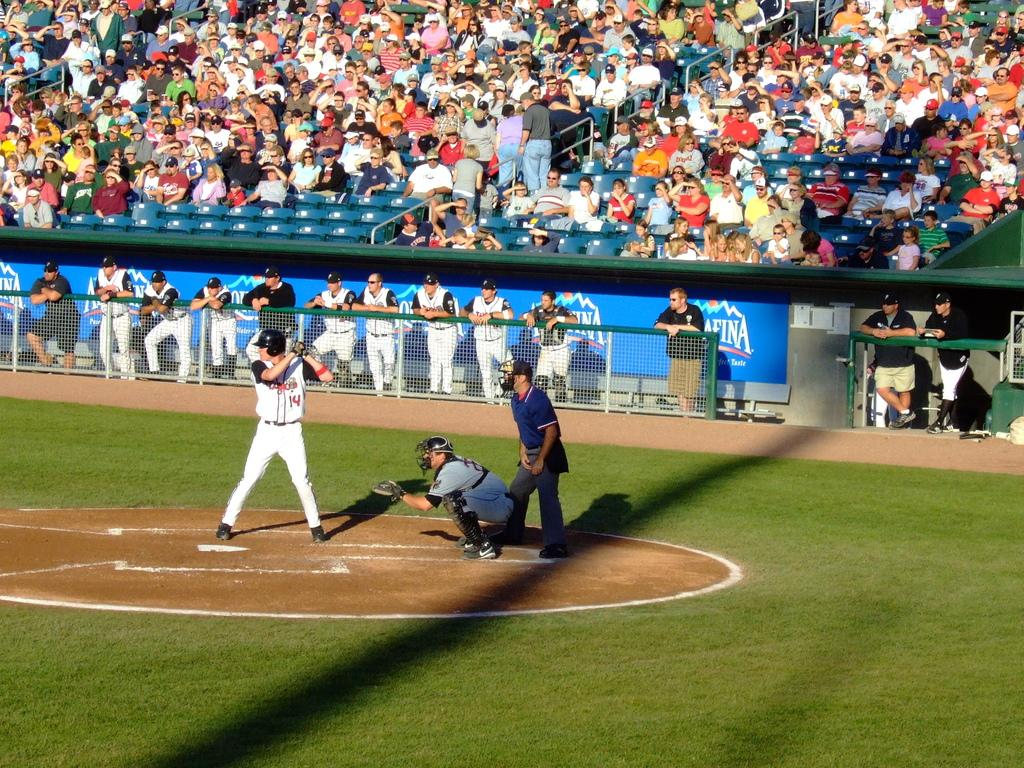<image>
Create a compact narrative representing the image presented. A man with a number 14 on his jersey prepares to hit a ball 